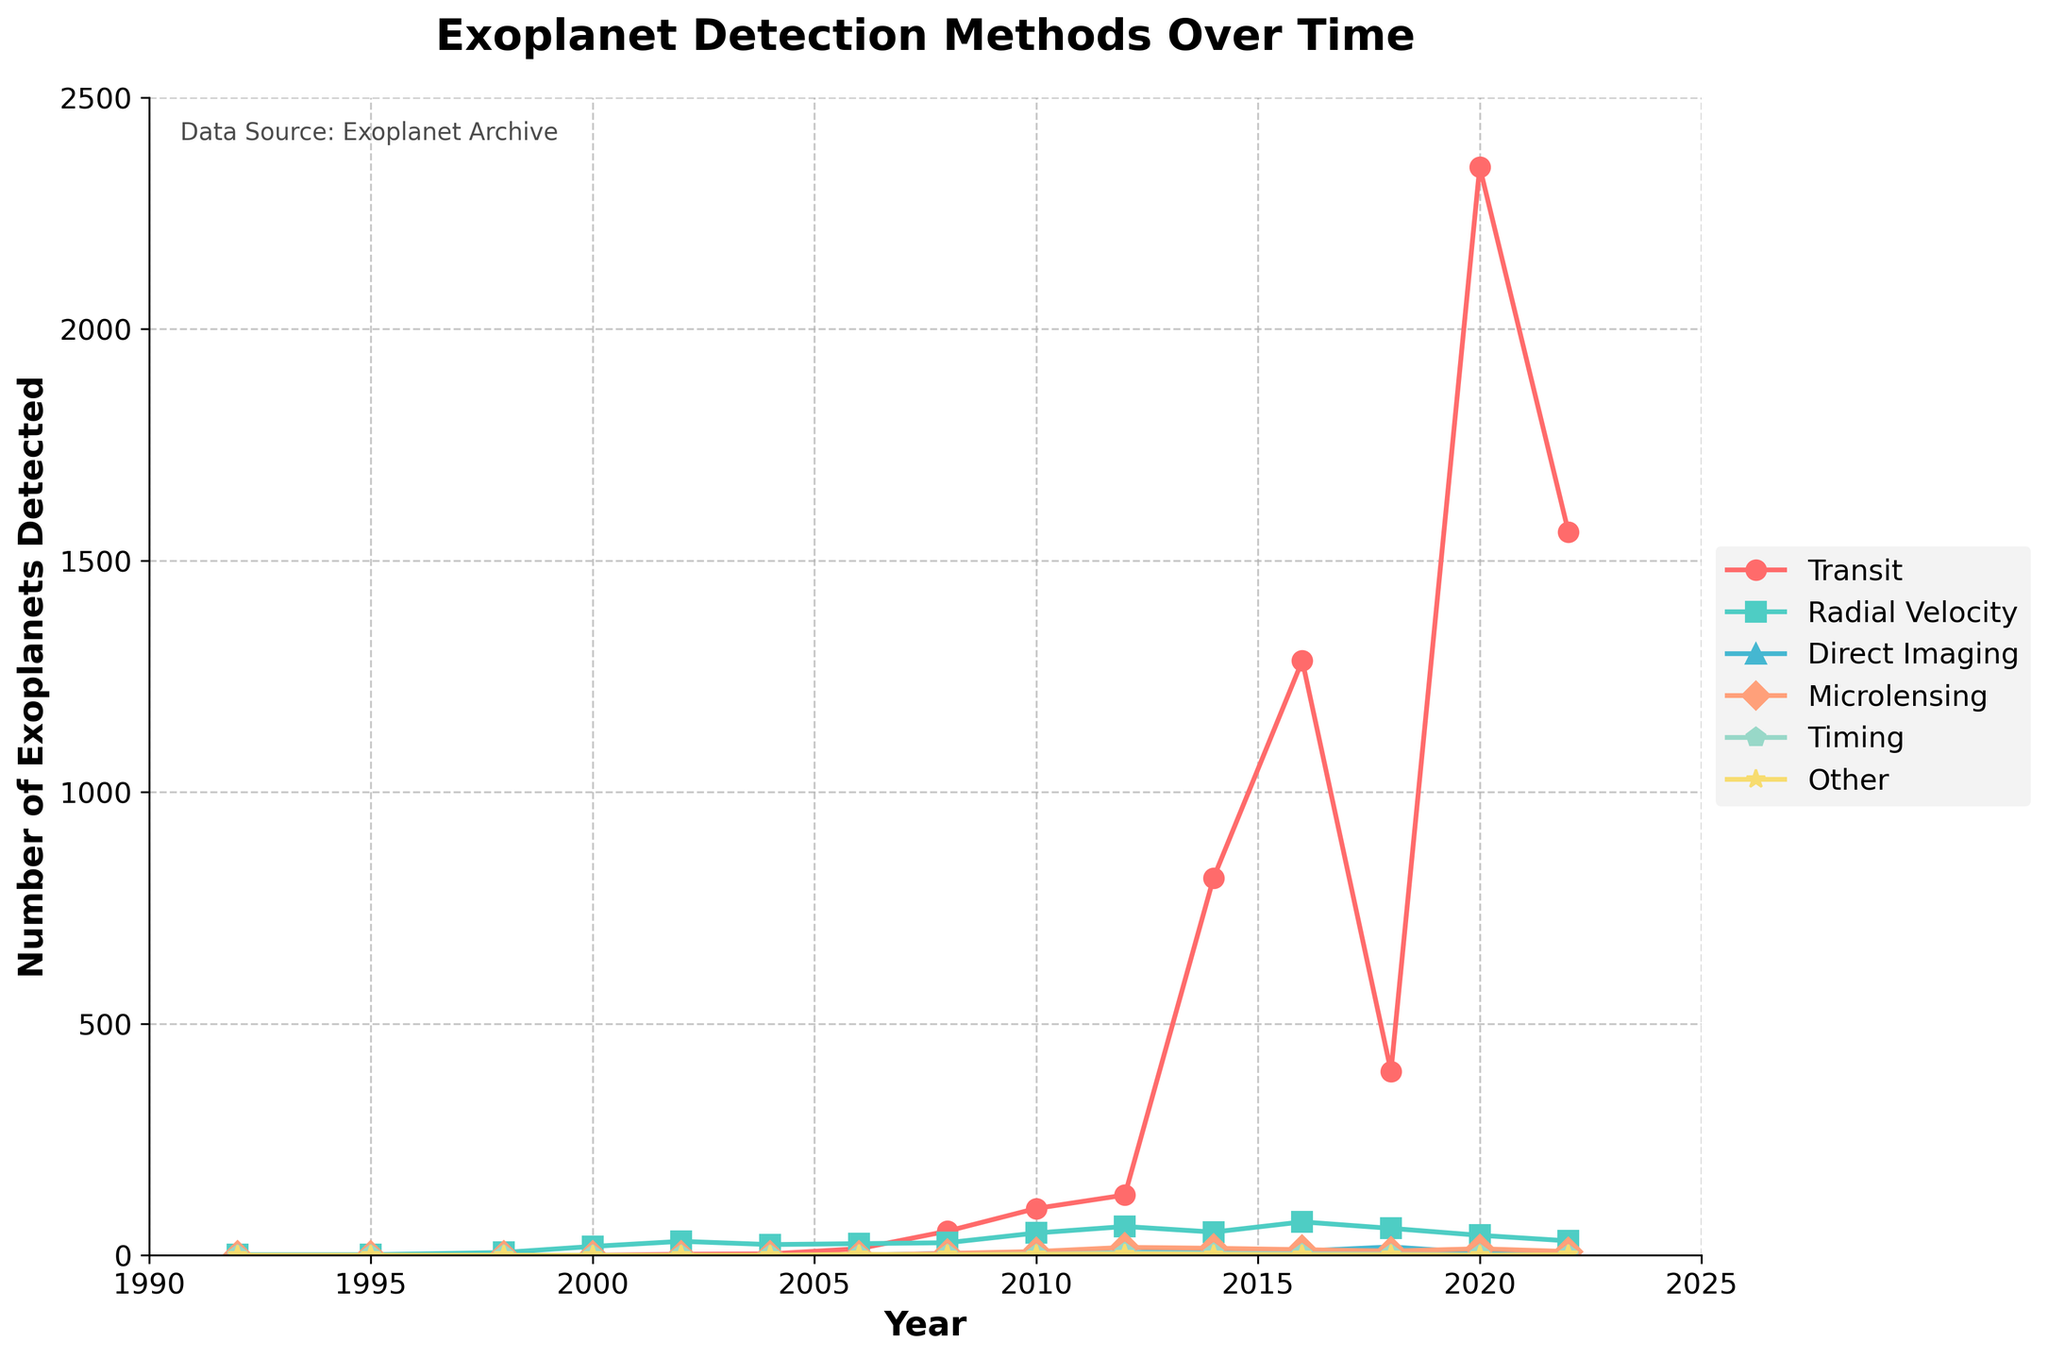What is the overall trend for the number of exoplanets detected by the Transit method from 1992 to 2022? Examining the figure, we observe that the number of exoplanets detected by the Transit method starts from 0 in 1992, shows a significant spike around 2014, peaks in 2020, and then slightly decreases by 2022. This indicates an overall increasing trend with a peak around 2020.
Answer: Increasing trend with a peak around 2020 Which detection method had the highest number of exoplanets detected in 2020? The figure shows that in 2020, the Transit method had a point significantly higher than all other methods, indicating it had the highest number of exoplanets detected.
Answer: Transit In which year did Radial Velocity detections peak, and what was the count? By observing Radial Velocity data points, the peak detection count is at its highest around 2002. Referencing the figure, the marker for Radial Velocity in 2002 is higher than in any other year. Summing it up, the count is 30.
Answer: 2002, 30 From 2010 to 2022, which detection method shows a decrease in the number of exoplanets detected? Comparing the visual heights of the markers from 2010 to 2022, the Radial Velocity method shows a clear decrease. The count drops from 48 in 2010 to 31 in 2022.
Answer: Radial Velocity Compare the total number of exoplanets detected by Microlensing and Transit in 2016. Which is higher and by how much? According to the figure, Microlensing has a count of 12 in 2016, while Transit has 1284. Subtracting these values, Transit exceeds Microlensing by: 1284 - 12 = 1272.
Answer: Transit by 1272 How does the number of detections for Direct Imaging change from 2008 to 2022? In the figure, Direct Imaging starts with a small count in 2008, slightly increases to 5 by 2012, reaches a peak around 2014 with 11 detections, and then generally shows a declining or stable trend, with 7 detections by 2022.
Answer: Initially increases, then stabilizes or decreases By how much did the number of detections for the "Other" method increase between 2018 and 2022? In the figure, the count for "Other" increases from 1 in 2018 to 1 in 2022. Checking these peaks' heights, the number of detections change is: 1 - 1 = 0.
Answer: 0 Which two detection methods have experienced a decline in the number of detections from their peak values? The figure shows that Radial Velocity peaks around 2002 and declines afterward, while Direct Imaging peaks around 2014 and dips thereafter. Confirming these observations, both face declines from their peak counts.
Answer: Radial Velocity and Direct Imaging What detection method shows the most significant visual spike between 2014 and 2016, and what is the approximate change in counts? Observing the figure, the Transit method shows the highest visual spike between 2014 (815 detections) and 2016 (1284 detections). The approximate change is: 1284 - 815 = 469.
Answer: Transit, 469 